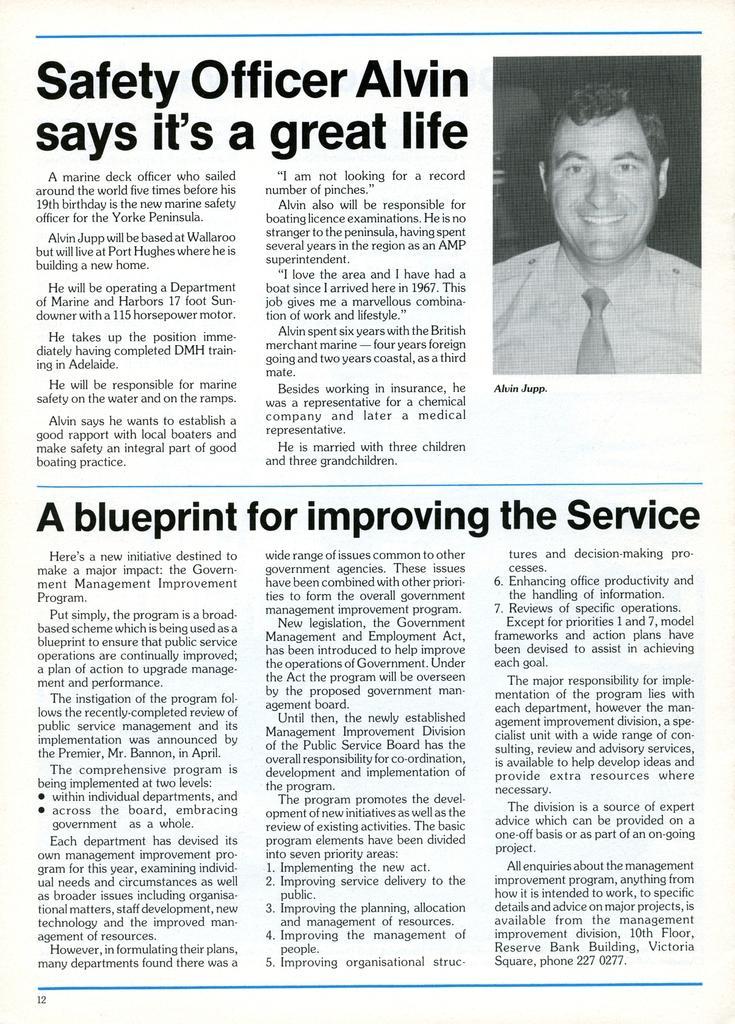Please provide a concise description of this image. In this picture we can see a white color object which seems to be the newspaper and we can see the picture of a person wearing shirt and smiling and we can see the text on the paper and we can see the numbers on the paper. 